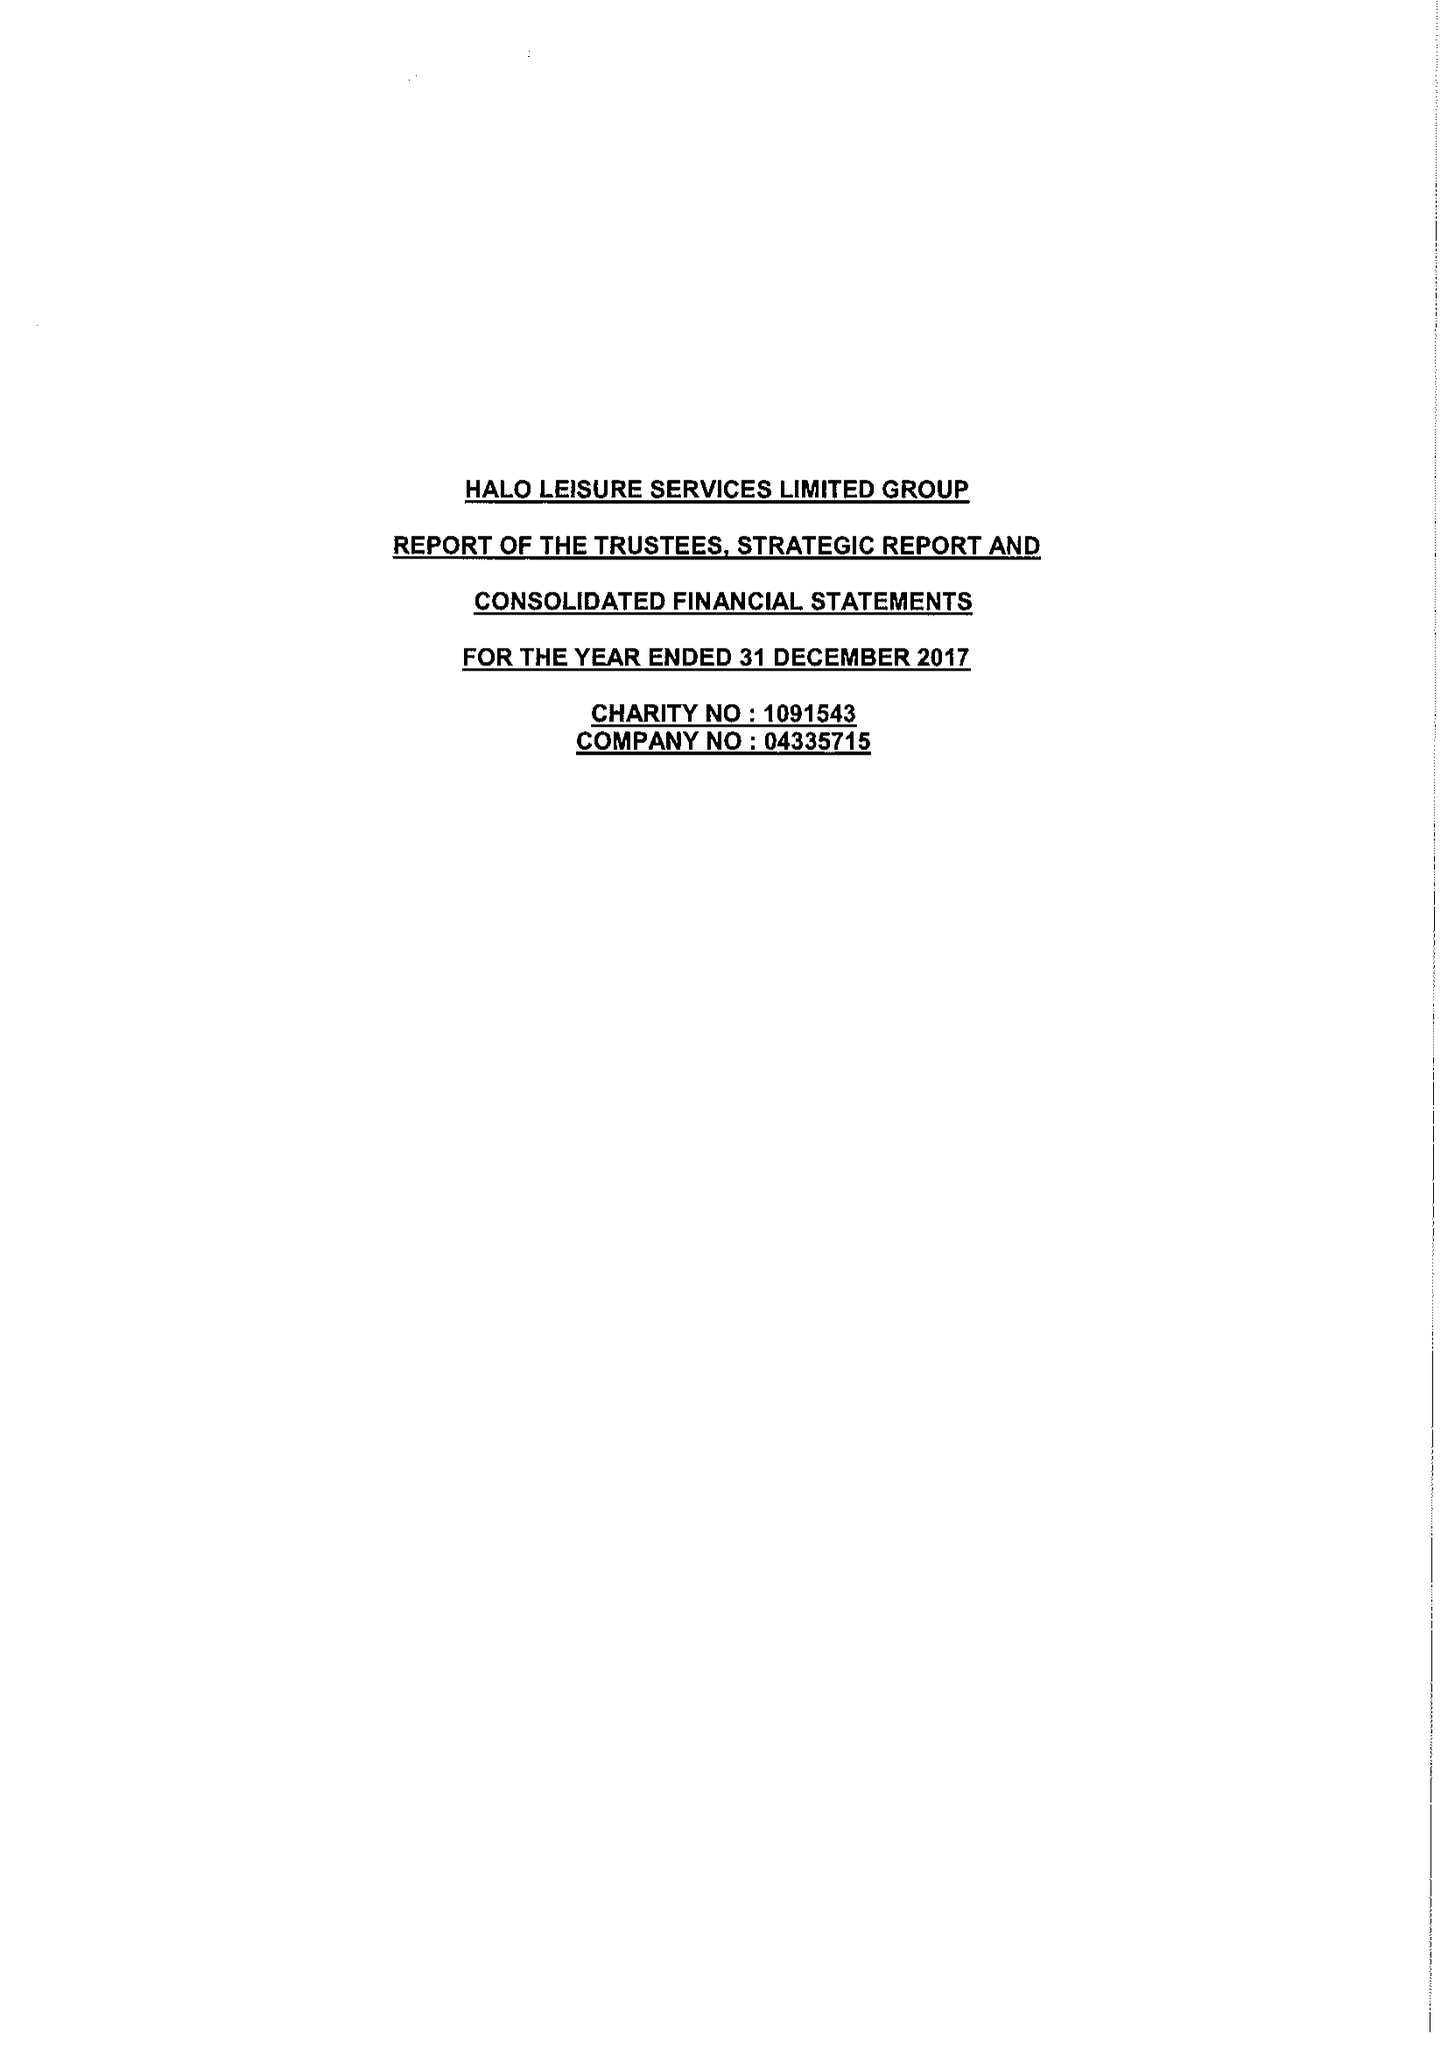What is the value for the charity_number?
Answer the question using a single word or phrase. 1091543 